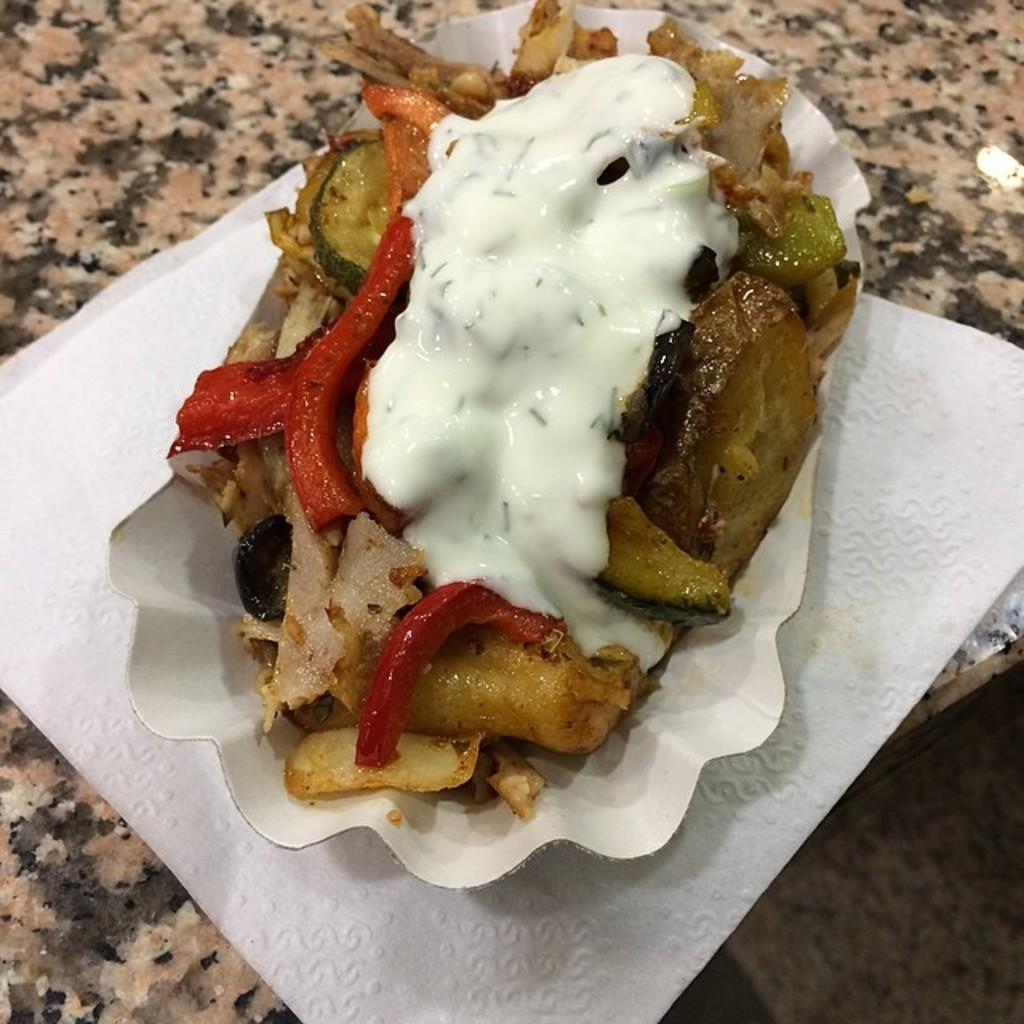What is the main subject of the picture? There is a food item in the picture. How is the food item contained or wrapped? The food item is in a paper. What is the paper resting on? The paper is on a tissue paper. What is the surface of the table made of? The tissue paper is on a stone table. What type of cherry is depicted in the history of the fly in the image? There is no cherry, history, or fly present in the image. 